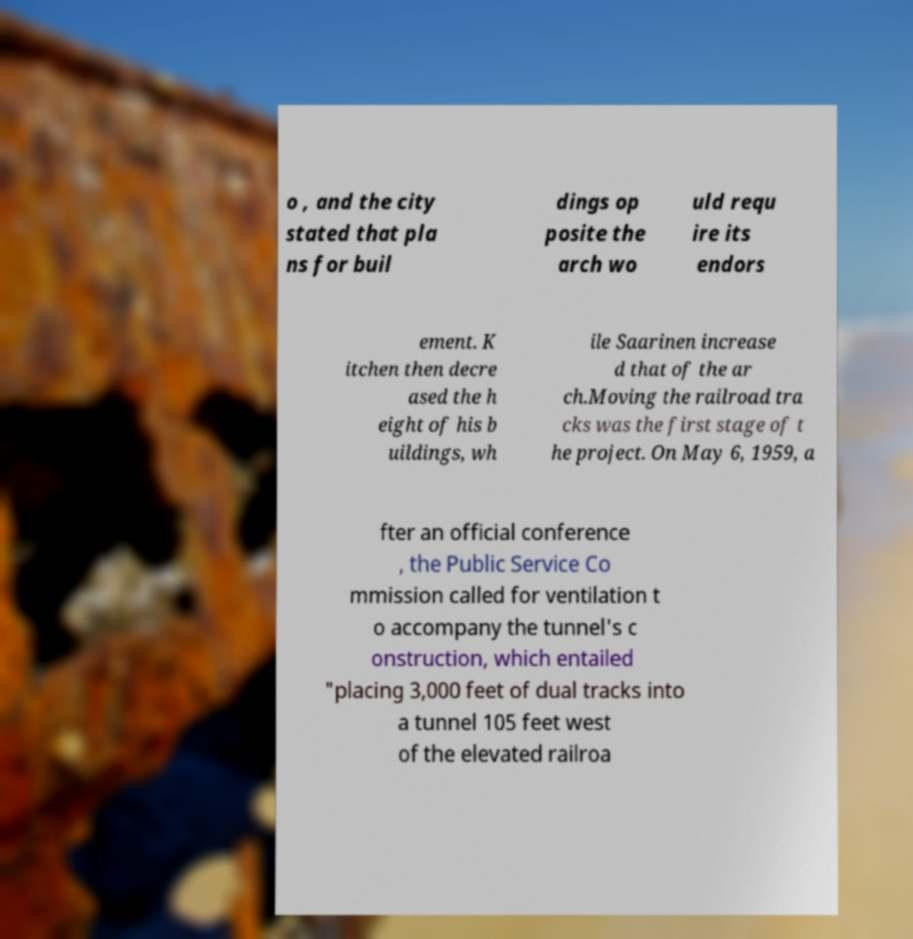Could you assist in decoding the text presented in this image and type it out clearly? o , and the city stated that pla ns for buil dings op posite the arch wo uld requ ire its endors ement. K itchen then decre ased the h eight of his b uildings, wh ile Saarinen increase d that of the ar ch.Moving the railroad tra cks was the first stage of t he project. On May 6, 1959, a fter an official conference , the Public Service Co mmission called for ventilation t o accompany the tunnel's c onstruction, which entailed "placing 3,000 feet of dual tracks into a tunnel 105 feet west of the elevated railroa 